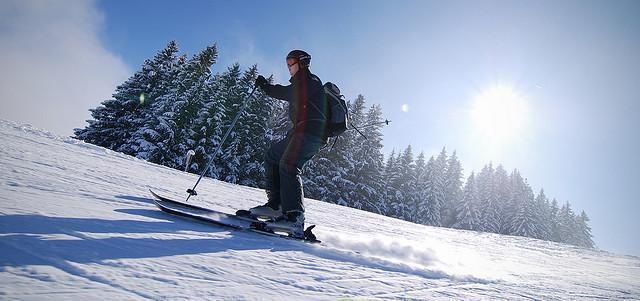What does the giant ball do?
Answer the question by selecting the correct answer among the 4 following choices and explain your choice with a short sentence. The answer should be formatted with the following format: `Answer: choice
Rationale: rationale.`
Options: Electrify, nuclear fusion, squeak, bounce. Answer: nuclear fusion.
Rationale: The sun is nuclear. 